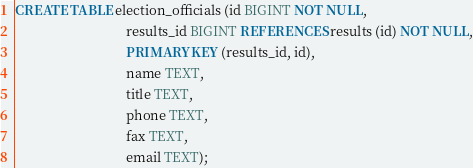<code> <loc_0><loc_0><loc_500><loc_500><_SQL_>CREATE TABLE election_officials (id BIGINT NOT NULL,
                                 results_id BIGINT REFERENCES results (id) NOT NULL,
                                 PRIMARY KEY (results_id, id),
                                 name TEXT,
                                 title TEXT,
                                 phone TEXT,
                                 fax TEXT,
                                 email TEXT);
</code> 